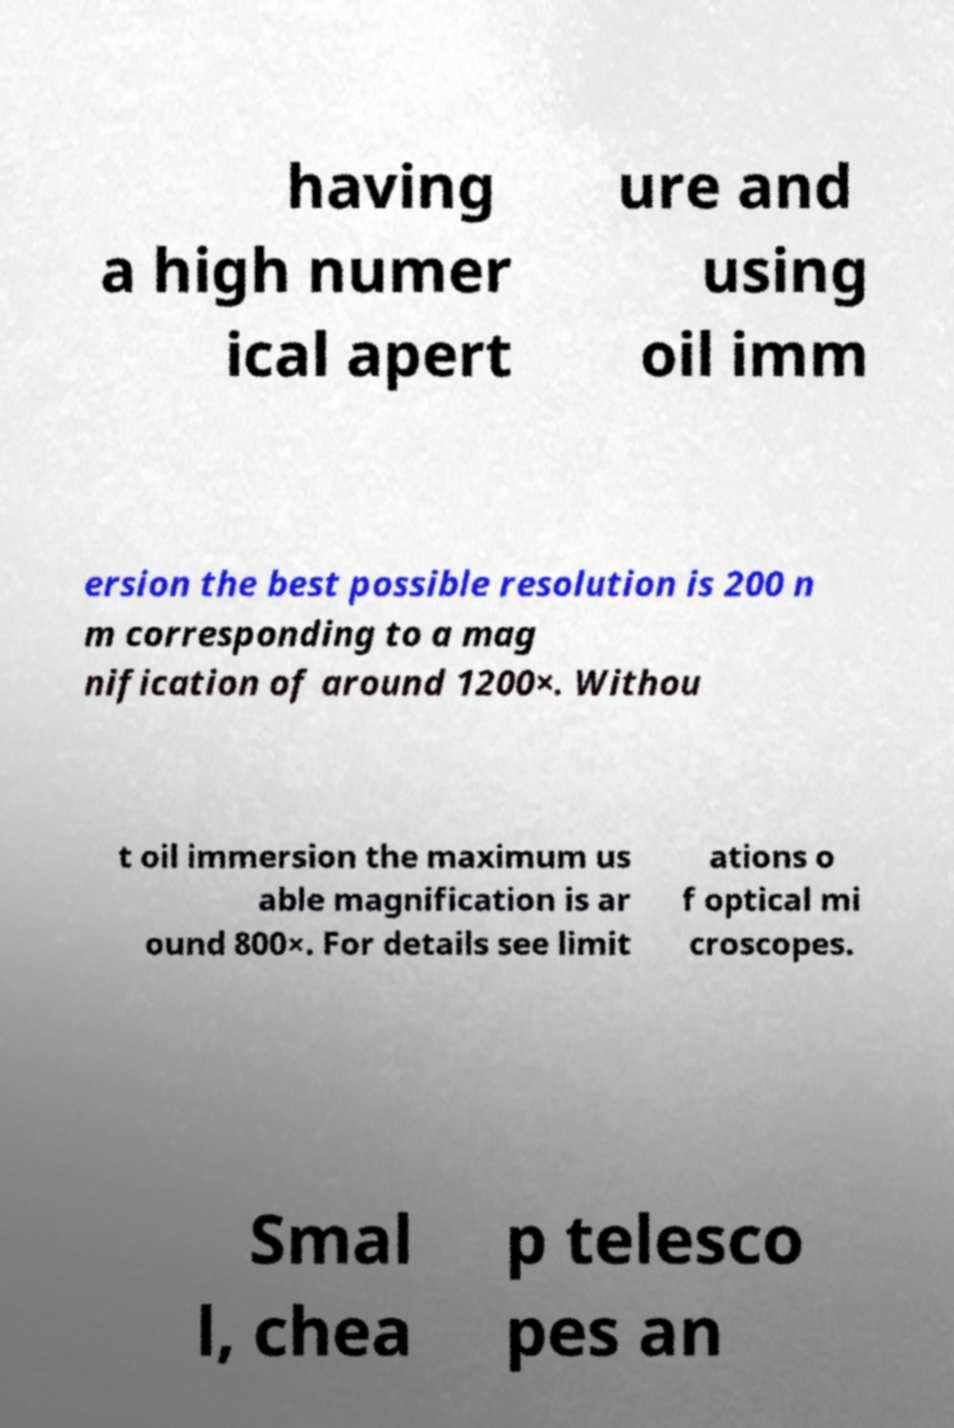Could you assist in decoding the text presented in this image and type it out clearly? having a high numer ical apert ure and using oil imm ersion the best possible resolution is 200 n m corresponding to a mag nification of around 1200×. Withou t oil immersion the maximum us able magnification is ar ound 800×. For details see limit ations o f optical mi croscopes. Smal l, chea p telesco pes an 